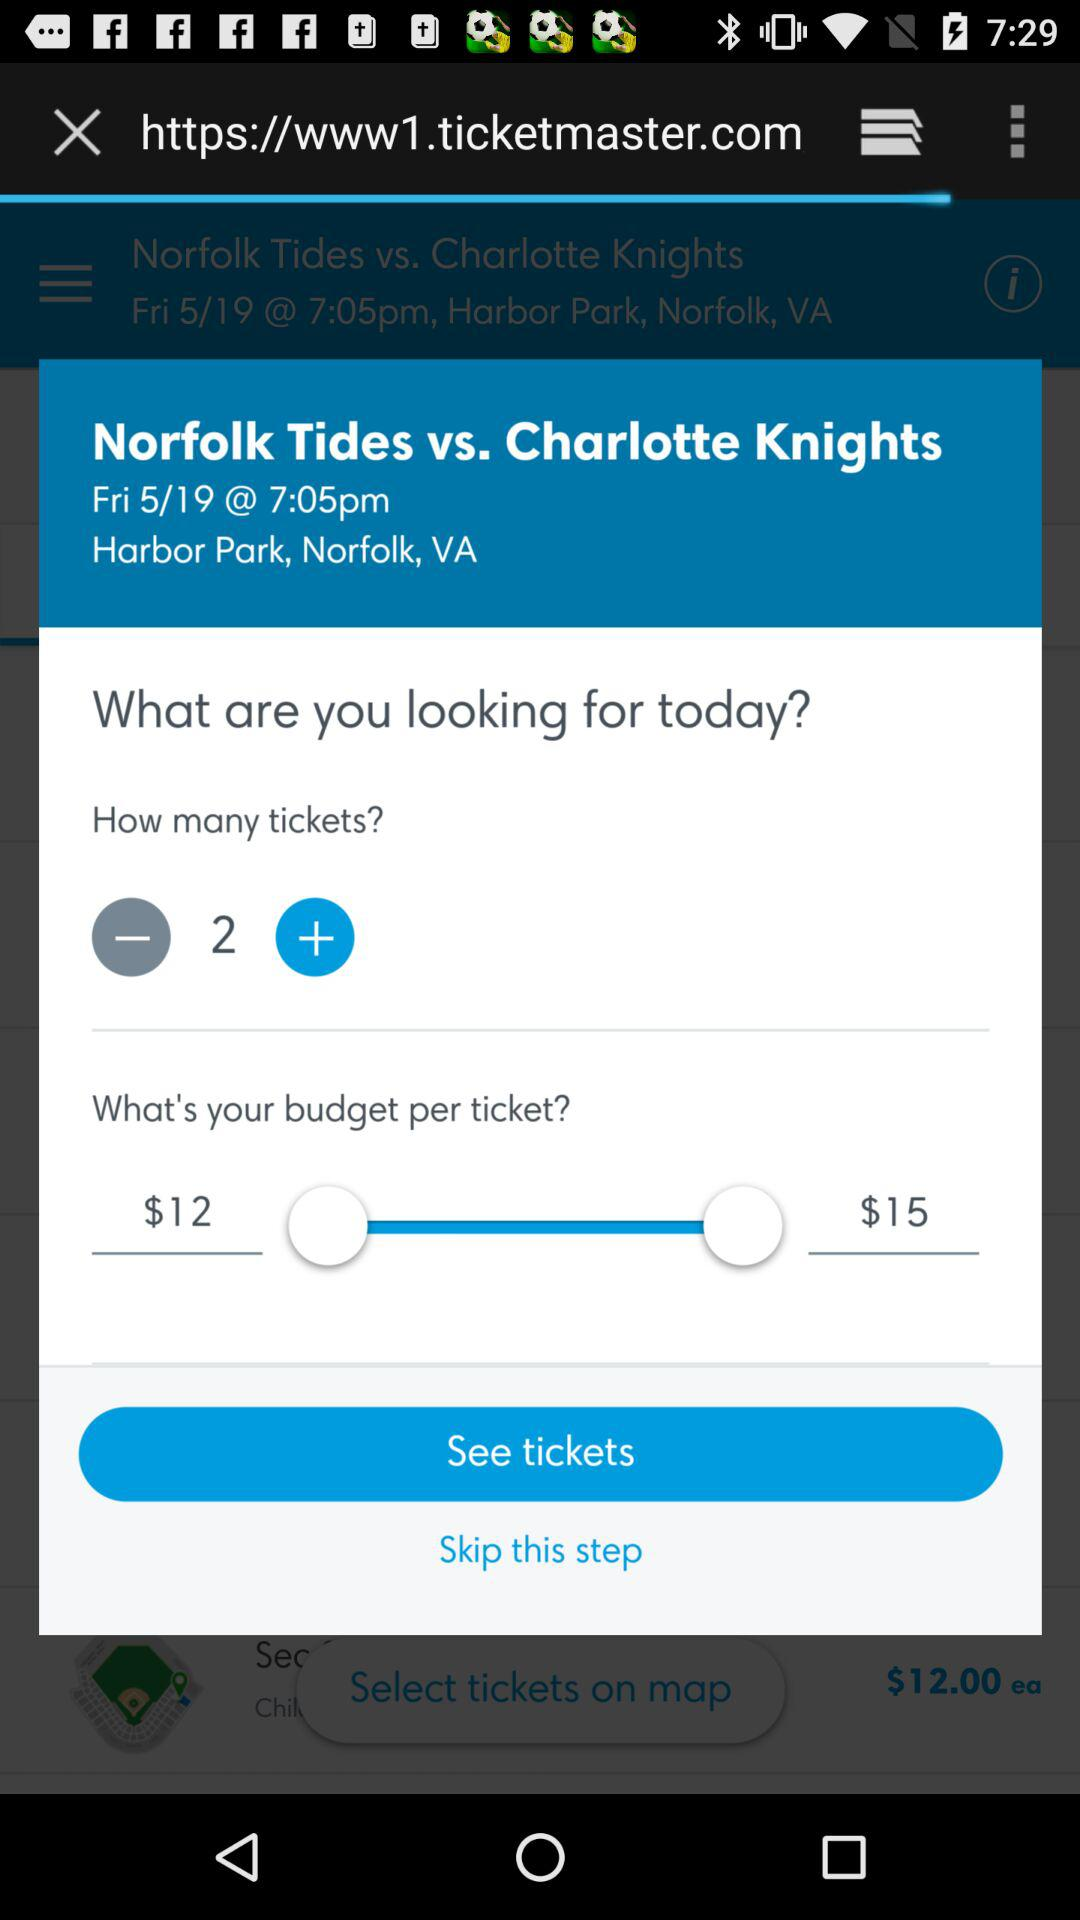What is the selected number of tickets? The selected number of tickets is 2. 